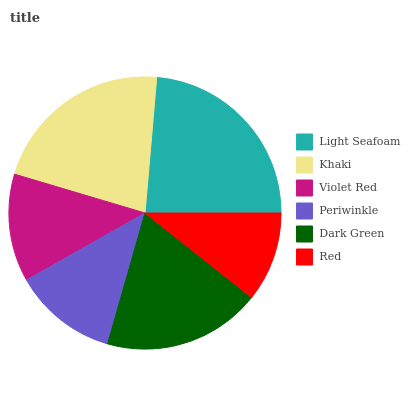Is Red the minimum?
Answer yes or no. Yes. Is Light Seafoam the maximum?
Answer yes or no. Yes. Is Khaki the minimum?
Answer yes or no. No. Is Khaki the maximum?
Answer yes or no. No. Is Light Seafoam greater than Khaki?
Answer yes or no. Yes. Is Khaki less than Light Seafoam?
Answer yes or no. Yes. Is Khaki greater than Light Seafoam?
Answer yes or no. No. Is Light Seafoam less than Khaki?
Answer yes or no. No. Is Dark Green the high median?
Answer yes or no. Yes. Is Violet Red the low median?
Answer yes or no. Yes. Is Red the high median?
Answer yes or no. No. Is Red the low median?
Answer yes or no. No. 